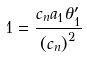<formula> <loc_0><loc_0><loc_500><loc_500>1 = \frac { c _ { n } a _ { 1 } \theta _ { 1 } ^ { \prime } } { \left ( c _ { n } \right ) ^ { 2 } }</formula> 